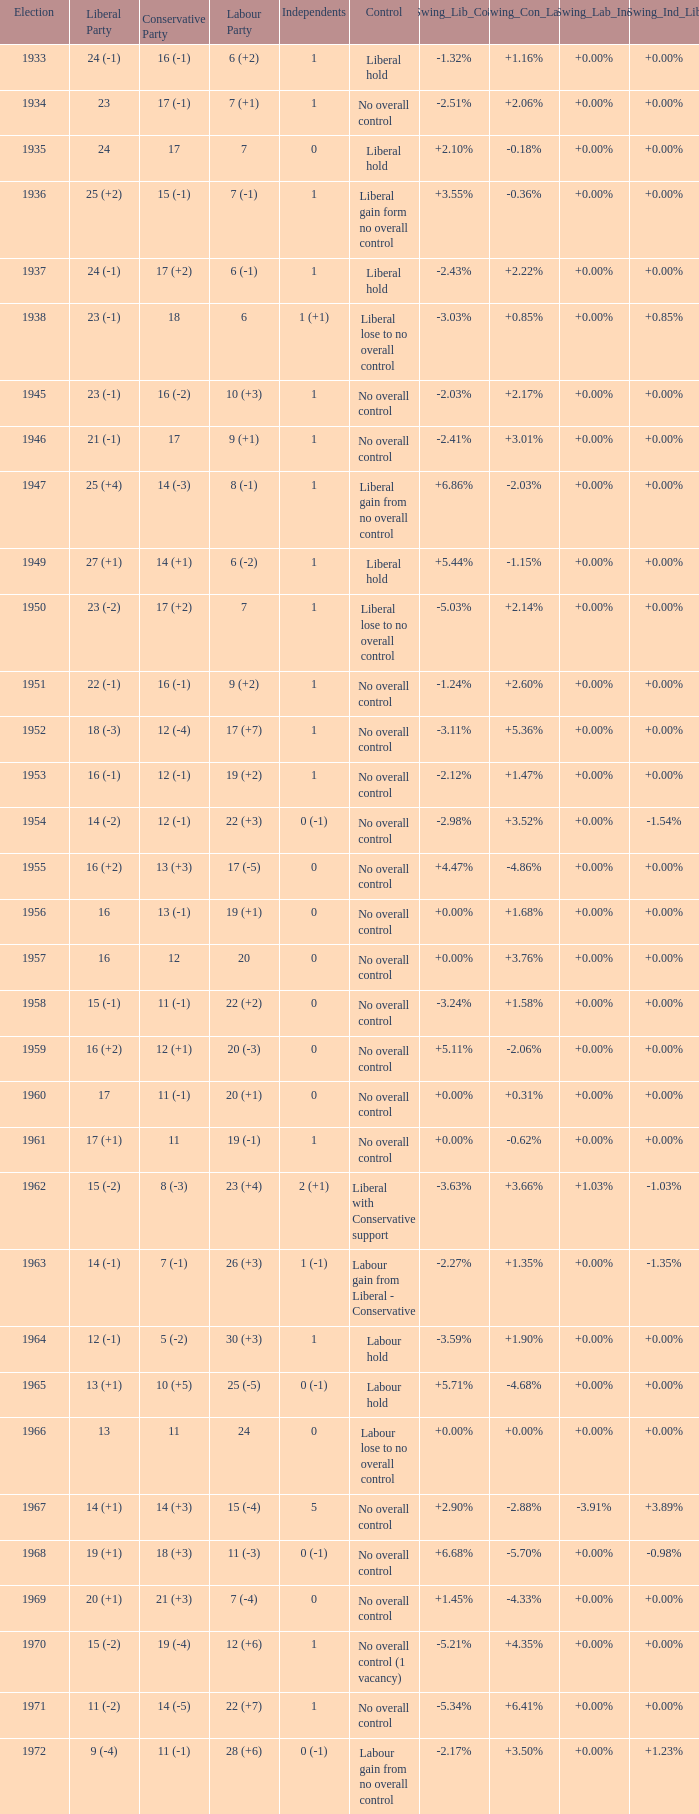Who was in control the year that Labour Party won 12 (+6) seats? No overall control (1 vacancy). 